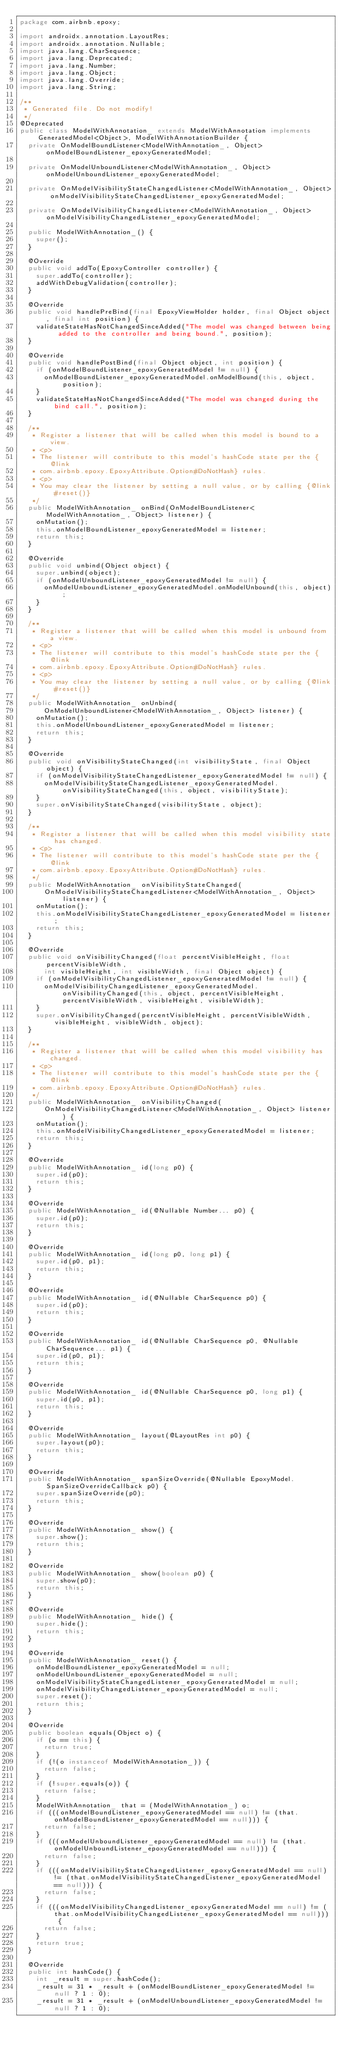<code> <loc_0><loc_0><loc_500><loc_500><_Java_>package com.airbnb.epoxy;

import androidx.annotation.LayoutRes;
import androidx.annotation.Nullable;
import java.lang.CharSequence;
import java.lang.Deprecated;
import java.lang.Number;
import java.lang.Object;
import java.lang.Override;
import java.lang.String;

/**
 * Generated file. Do not modify!
 */
@Deprecated
public class ModelWithAnnotation_ extends ModelWithAnnotation implements GeneratedModel<Object>, ModelWithAnnotationBuilder {
  private OnModelBoundListener<ModelWithAnnotation_, Object> onModelBoundListener_epoxyGeneratedModel;

  private OnModelUnboundListener<ModelWithAnnotation_, Object> onModelUnboundListener_epoxyGeneratedModel;

  private OnModelVisibilityStateChangedListener<ModelWithAnnotation_, Object> onModelVisibilityStateChangedListener_epoxyGeneratedModel;

  private OnModelVisibilityChangedListener<ModelWithAnnotation_, Object> onModelVisibilityChangedListener_epoxyGeneratedModel;

  public ModelWithAnnotation_() {
    super();
  }

  @Override
  public void addTo(EpoxyController controller) {
    super.addTo(controller);
    addWithDebugValidation(controller);
  }

  @Override
  public void handlePreBind(final EpoxyViewHolder holder, final Object object, final int position) {
    validateStateHasNotChangedSinceAdded("The model was changed between being added to the controller and being bound.", position);
  }

  @Override
  public void handlePostBind(final Object object, int position) {
    if (onModelBoundListener_epoxyGeneratedModel != null) {
      onModelBoundListener_epoxyGeneratedModel.onModelBound(this, object, position);
    }
    validateStateHasNotChangedSinceAdded("The model was changed during the bind call.", position);
  }

  /**
   * Register a listener that will be called when this model is bound to a view.
   * <p>
   * The listener will contribute to this model's hashCode state per the {@link
   * com.airbnb.epoxy.EpoxyAttribute.Option#DoNotHash} rules.
   * <p>
   * You may clear the listener by setting a null value, or by calling {@link #reset()}
   */
  public ModelWithAnnotation_ onBind(OnModelBoundListener<ModelWithAnnotation_, Object> listener) {
    onMutation();
    this.onModelBoundListener_epoxyGeneratedModel = listener;
    return this;
  }

  @Override
  public void unbind(Object object) {
    super.unbind(object);
    if (onModelUnboundListener_epoxyGeneratedModel != null) {
      onModelUnboundListener_epoxyGeneratedModel.onModelUnbound(this, object);
    }
  }

  /**
   * Register a listener that will be called when this model is unbound from a view.
   * <p>
   * The listener will contribute to this model's hashCode state per the {@link
   * com.airbnb.epoxy.EpoxyAttribute.Option#DoNotHash} rules.
   * <p>
   * You may clear the listener by setting a null value, or by calling {@link #reset()}
   */
  public ModelWithAnnotation_ onUnbind(
      OnModelUnboundListener<ModelWithAnnotation_, Object> listener) {
    onMutation();
    this.onModelUnboundListener_epoxyGeneratedModel = listener;
    return this;
  }

  @Override
  public void onVisibilityStateChanged(int visibilityState, final Object object) {
    if (onModelVisibilityStateChangedListener_epoxyGeneratedModel != null) {
      onModelVisibilityStateChangedListener_epoxyGeneratedModel.onVisibilityStateChanged(this, object, visibilityState);
    }
    super.onVisibilityStateChanged(visibilityState, object);
  }

  /**
   * Register a listener that will be called when this model visibility state has changed.
   * <p>
   * The listener will contribute to this model's hashCode state per the {@link
   * com.airbnb.epoxy.EpoxyAttribute.Option#DoNotHash} rules.
   */
  public ModelWithAnnotation_ onVisibilityStateChanged(
      OnModelVisibilityStateChangedListener<ModelWithAnnotation_, Object> listener) {
    onMutation();
    this.onModelVisibilityStateChangedListener_epoxyGeneratedModel = listener;
    return this;
  }

  @Override
  public void onVisibilityChanged(float percentVisibleHeight, float percentVisibleWidth,
      int visibleHeight, int visibleWidth, final Object object) {
    if (onModelVisibilityChangedListener_epoxyGeneratedModel != null) {
      onModelVisibilityChangedListener_epoxyGeneratedModel.onVisibilityChanged(this, object, percentVisibleHeight, percentVisibleWidth, visibleHeight, visibleWidth);
    }
    super.onVisibilityChanged(percentVisibleHeight, percentVisibleWidth, visibleHeight, visibleWidth, object);
  }

  /**
   * Register a listener that will be called when this model visibility has changed.
   * <p>
   * The listener will contribute to this model's hashCode state per the {@link
   * com.airbnb.epoxy.EpoxyAttribute.Option#DoNotHash} rules.
   */
  public ModelWithAnnotation_ onVisibilityChanged(
      OnModelVisibilityChangedListener<ModelWithAnnotation_, Object> listener) {
    onMutation();
    this.onModelVisibilityChangedListener_epoxyGeneratedModel = listener;
    return this;
  }

  @Override
  public ModelWithAnnotation_ id(long p0) {
    super.id(p0);
    return this;
  }

  @Override
  public ModelWithAnnotation_ id(@Nullable Number... p0) {
    super.id(p0);
    return this;
  }

  @Override
  public ModelWithAnnotation_ id(long p0, long p1) {
    super.id(p0, p1);
    return this;
  }

  @Override
  public ModelWithAnnotation_ id(@Nullable CharSequence p0) {
    super.id(p0);
    return this;
  }

  @Override
  public ModelWithAnnotation_ id(@Nullable CharSequence p0, @Nullable CharSequence... p1) {
    super.id(p0, p1);
    return this;
  }

  @Override
  public ModelWithAnnotation_ id(@Nullable CharSequence p0, long p1) {
    super.id(p0, p1);
    return this;
  }

  @Override
  public ModelWithAnnotation_ layout(@LayoutRes int p0) {
    super.layout(p0);
    return this;
  }

  @Override
  public ModelWithAnnotation_ spanSizeOverride(@Nullable EpoxyModel.SpanSizeOverrideCallback p0) {
    super.spanSizeOverride(p0);
    return this;
  }

  @Override
  public ModelWithAnnotation_ show() {
    super.show();
    return this;
  }

  @Override
  public ModelWithAnnotation_ show(boolean p0) {
    super.show(p0);
    return this;
  }

  @Override
  public ModelWithAnnotation_ hide() {
    super.hide();
    return this;
  }

  @Override
  public ModelWithAnnotation_ reset() {
    onModelBoundListener_epoxyGeneratedModel = null;
    onModelUnboundListener_epoxyGeneratedModel = null;
    onModelVisibilityStateChangedListener_epoxyGeneratedModel = null;
    onModelVisibilityChangedListener_epoxyGeneratedModel = null;
    super.reset();
    return this;
  }

  @Override
  public boolean equals(Object o) {
    if (o == this) {
      return true;
    }
    if (!(o instanceof ModelWithAnnotation_)) {
      return false;
    }
    if (!super.equals(o)) {
      return false;
    }
    ModelWithAnnotation_ that = (ModelWithAnnotation_) o;
    if (((onModelBoundListener_epoxyGeneratedModel == null) != (that.onModelBoundListener_epoxyGeneratedModel == null))) {
      return false;
    }
    if (((onModelUnboundListener_epoxyGeneratedModel == null) != (that.onModelUnboundListener_epoxyGeneratedModel == null))) {
      return false;
    }
    if (((onModelVisibilityStateChangedListener_epoxyGeneratedModel == null) != (that.onModelVisibilityStateChangedListener_epoxyGeneratedModel == null))) {
      return false;
    }
    if (((onModelVisibilityChangedListener_epoxyGeneratedModel == null) != (that.onModelVisibilityChangedListener_epoxyGeneratedModel == null))) {
      return false;
    }
    return true;
  }

  @Override
  public int hashCode() {
    int _result = super.hashCode();
    _result = 31 * _result + (onModelBoundListener_epoxyGeneratedModel != null ? 1 : 0);
    _result = 31 * _result + (onModelUnboundListener_epoxyGeneratedModel != null ? 1 : 0);</code> 